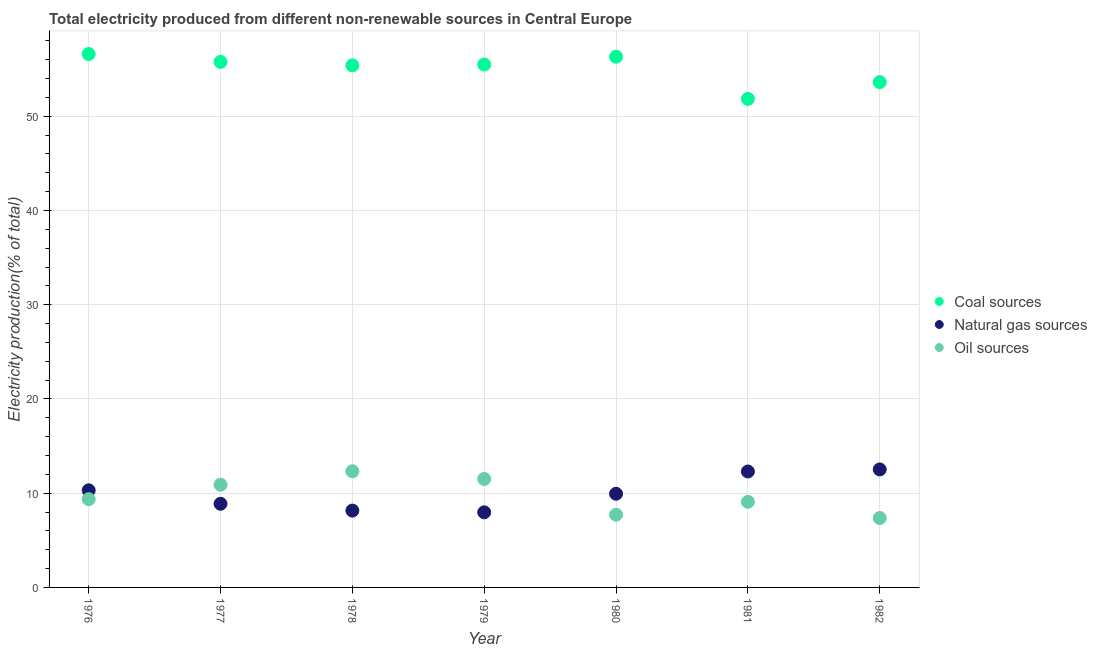How many different coloured dotlines are there?
Ensure brevity in your answer.  3. What is the percentage of electricity produced by oil sources in 1981?
Offer a very short reply. 9.09. Across all years, what is the maximum percentage of electricity produced by coal?
Offer a terse response. 56.61. Across all years, what is the minimum percentage of electricity produced by coal?
Keep it short and to the point. 51.85. In which year was the percentage of electricity produced by coal maximum?
Ensure brevity in your answer.  1976. In which year was the percentage of electricity produced by natural gas minimum?
Your response must be concise. 1979. What is the total percentage of electricity produced by natural gas in the graph?
Your response must be concise. 70.08. What is the difference between the percentage of electricity produced by oil sources in 1976 and that in 1977?
Your answer should be very brief. -1.53. What is the difference between the percentage of electricity produced by coal in 1981 and the percentage of electricity produced by oil sources in 1976?
Offer a very short reply. 42.49. What is the average percentage of electricity produced by coal per year?
Offer a terse response. 55.01. In the year 1981, what is the difference between the percentage of electricity produced by oil sources and percentage of electricity produced by coal?
Give a very brief answer. -42.77. What is the ratio of the percentage of electricity produced by coal in 1977 to that in 1982?
Make the answer very short. 1.04. Is the percentage of electricity produced by oil sources in 1978 less than that in 1982?
Keep it short and to the point. No. What is the difference between the highest and the second highest percentage of electricity produced by natural gas?
Your response must be concise. 0.22. What is the difference between the highest and the lowest percentage of electricity produced by oil sources?
Offer a very short reply. 4.96. In how many years, is the percentage of electricity produced by coal greater than the average percentage of electricity produced by coal taken over all years?
Ensure brevity in your answer.  5. Is the sum of the percentage of electricity produced by natural gas in 1981 and 1982 greater than the maximum percentage of electricity produced by oil sources across all years?
Keep it short and to the point. Yes. Does the percentage of electricity produced by natural gas monotonically increase over the years?
Keep it short and to the point. No. Are the values on the major ticks of Y-axis written in scientific E-notation?
Ensure brevity in your answer.  No. Where does the legend appear in the graph?
Make the answer very short. Center right. How many legend labels are there?
Make the answer very short. 3. What is the title of the graph?
Provide a short and direct response. Total electricity produced from different non-renewable sources in Central Europe. Does "Tertiary education" appear as one of the legend labels in the graph?
Keep it short and to the point. No. What is the Electricity production(% of total) of Coal sources in 1976?
Keep it short and to the point. 56.61. What is the Electricity production(% of total) of Natural gas sources in 1976?
Your answer should be very brief. 10.31. What is the Electricity production(% of total) of Oil sources in 1976?
Offer a terse response. 9.37. What is the Electricity production(% of total) in Coal sources in 1977?
Make the answer very short. 55.77. What is the Electricity production(% of total) of Natural gas sources in 1977?
Your answer should be compact. 8.87. What is the Electricity production(% of total) in Oil sources in 1977?
Your answer should be very brief. 10.9. What is the Electricity production(% of total) of Coal sources in 1978?
Give a very brief answer. 55.41. What is the Electricity production(% of total) in Natural gas sources in 1978?
Provide a short and direct response. 8.15. What is the Electricity production(% of total) of Oil sources in 1978?
Give a very brief answer. 12.33. What is the Electricity production(% of total) in Coal sources in 1979?
Make the answer very short. 55.5. What is the Electricity production(% of total) in Natural gas sources in 1979?
Make the answer very short. 7.97. What is the Electricity production(% of total) of Oil sources in 1979?
Offer a very short reply. 11.52. What is the Electricity production(% of total) of Coal sources in 1980?
Offer a terse response. 56.32. What is the Electricity production(% of total) of Natural gas sources in 1980?
Provide a succinct answer. 9.94. What is the Electricity production(% of total) in Oil sources in 1980?
Offer a very short reply. 7.72. What is the Electricity production(% of total) of Coal sources in 1981?
Your answer should be compact. 51.85. What is the Electricity production(% of total) in Natural gas sources in 1981?
Offer a very short reply. 12.3. What is the Electricity production(% of total) of Oil sources in 1981?
Keep it short and to the point. 9.09. What is the Electricity production(% of total) in Coal sources in 1982?
Provide a succinct answer. 53.63. What is the Electricity production(% of total) of Natural gas sources in 1982?
Make the answer very short. 12.52. What is the Electricity production(% of total) in Oil sources in 1982?
Keep it short and to the point. 7.36. Across all years, what is the maximum Electricity production(% of total) of Coal sources?
Ensure brevity in your answer.  56.61. Across all years, what is the maximum Electricity production(% of total) of Natural gas sources?
Offer a terse response. 12.52. Across all years, what is the maximum Electricity production(% of total) in Oil sources?
Provide a succinct answer. 12.33. Across all years, what is the minimum Electricity production(% of total) in Coal sources?
Keep it short and to the point. 51.85. Across all years, what is the minimum Electricity production(% of total) in Natural gas sources?
Give a very brief answer. 7.97. Across all years, what is the minimum Electricity production(% of total) in Oil sources?
Your answer should be compact. 7.36. What is the total Electricity production(% of total) of Coal sources in the graph?
Offer a very short reply. 385.09. What is the total Electricity production(% of total) of Natural gas sources in the graph?
Offer a very short reply. 70.08. What is the total Electricity production(% of total) of Oil sources in the graph?
Provide a short and direct response. 68.28. What is the difference between the Electricity production(% of total) in Coal sources in 1976 and that in 1977?
Offer a very short reply. 0.84. What is the difference between the Electricity production(% of total) in Natural gas sources in 1976 and that in 1977?
Ensure brevity in your answer.  1.43. What is the difference between the Electricity production(% of total) in Oil sources in 1976 and that in 1977?
Ensure brevity in your answer.  -1.53. What is the difference between the Electricity production(% of total) of Coal sources in 1976 and that in 1978?
Give a very brief answer. 1.2. What is the difference between the Electricity production(% of total) of Natural gas sources in 1976 and that in 1978?
Provide a short and direct response. 2.15. What is the difference between the Electricity production(% of total) in Oil sources in 1976 and that in 1978?
Give a very brief answer. -2.96. What is the difference between the Electricity production(% of total) of Coal sources in 1976 and that in 1979?
Make the answer very short. 1.11. What is the difference between the Electricity production(% of total) of Natural gas sources in 1976 and that in 1979?
Your response must be concise. 2.34. What is the difference between the Electricity production(% of total) in Oil sources in 1976 and that in 1979?
Offer a very short reply. -2.15. What is the difference between the Electricity production(% of total) in Coal sources in 1976 and that in 1980?
Provide a succinct answer. 0.28. What is the difference between the Electricity production(% of total) of Natural gas sources in 1976 and that in 1980?
Ensure brevity in your answer.  0.37. What is the difference between the Electricity production(% of total) in Oil sources in 1976 and that in 1980?
Your answer should be very brief. 1.65. What is the difference between the Electricity production(% of total) in Coal sources in 1976 and that in 1981?
Ensure brevity in your answer.  4.76. What is the difference between the Electricity production(% of total) in Natural gas sources in 1976 and that in 1981?
Ensure brevity in your answer.  -2. What is the difference between the Electricity production(% of total) of Oil sources in 1976 and that in 1981?
Ensure brevity in your answer.  0.28. What is the difference between the Electricity production(% of total) of Coal sources in 1976 and that in 1982?
Your response must be concise. 2.98. What is the difference between the Electricity production(% of total) in Natural gas sources in 1976 and that in 1982?
Give a very brief answer. -2.22. What is the difference between the Electricity production(% of total) in Oil sources in 1976 and that in 1982?
Provide a short and direct response. 2. What is the difference between the Electricity production(% of total) in Coal sources in 1977 and that in 1978?
Provide a short and direct response. 0.36. What is the difference between the Electricity production(% of total) in Natural gas sources in 1977 and that in 1978?
Ensure brevity in your answer.  0.72. What is the difference between the Electricity production(% of total) of Oil sources in 1977 and that in 1978?
Provide a succinct answer. -1.43. What is the difference between the Electricity production(% of total) in Coal sources in 1977 and that in 1979?
Give a very brief answer. 0.28. What is the difference between the Electricity production(% of total) of Natural gas sources in 1977 and that in 1979?
Your answer should be very brief. 0.9. What is the difference between the Electricity production(% of total) in Oil sources in 1977 and that in 1979?
Your answer should be compact. -0.62. What is the difference between the Electricity production(% of total) of Coal sources in 1977 and that in 1980?
Ensure brevity in your answer.  -0.55. What is the difference between the Electricity production(% of total) of Natural gas sources in 1977 and that in 1980?
Give a very brief answer. -1.07. What is the difference between the Electricity production(% of total) in Oil sources in 1977 and that in 1980?
Provide a short and direct response. 3.18. What is the difference between the Electricity production(% of total) of Coal sources in 1977 and that in 1981?
Offer a very short reply. 3.92. What is the difference between the Electricity production(% of total) in Natural gas sources in 1977 and that in 1981?
Provide a short and direct response. -3.43. What is the difference between the Electricity production(% of total) of Oil sources in 1977 and that in 1981?
Your response must be concise. 1.81. What is the difference between the Electricity production(% of total) in Coal sources in 1977 and that in 1982?
Provide a succinct answer. 2.14. What is the difference between the Electricity production(% of total) in Natural gas sources in 1977 and that in 1982?
Your response must be concise. -3.65. What is the difference between the Electricity production(% of total) in Oil sources in 1977 and that in 1982?
Keep it short and to the point. 3.53. What is the difference between the Electricity production(% of total) in Coal sources in 1978 and that in 1979?
Your answer should be compact. -0.09. What is the difference between the Electricity production(% of total) of Natural gas sources in 1978 and that in 1979?
Your answer should be very brief. 0.18. What is the difference between the Electricity production(% of total) of Oil sources in 1978 and that in 1979?
Provide a short and direct response. 0.81. What is the difference between the Electricity production(% of total) of Coal sources in 1978 and that in 1980?
Your answer should be compact. -0.92. What is the difference between the Electricity production(% of total) of Natural gas sources in 1978 and that in 1980?
Give a very brief answer. -1.79. What is the difference between the Electricity production(% of total) of Oil sources in 1978 and that in 1980?
Make the answer very short. 4.61. What is the difference between the Electricity production(% of total) of Coal sources in 1978 and that in 1981?
Your response must be concise. 3.56. What is the difference between the Electricity production(% of total) in Natural gas sources in 1978 and that in 1981?
Offer a very short reply. -4.15. What is the difference between the Electricity production(% of total) of Oil sources in 1978 and that in 1981?
Offer a terse response. 3.24. What is the difference between the Electricity production(% of total) in Coal sources in 1978 and that in 1982?
Offer a very short reply. 1.78. What is the difference between the Electricity production(% of total) in Natural gas sources in 1978 and that in 1982?
Offer a terse response. -4.37. What is the difference between the Electricity production(% of total) of Oil sources in 1978 and that in 1982?
Offer a terse response. 4.96. What is the difference between the Electricity production(% of total) of Coal sources in 1979 and that in 1980?
Provide a short and direct response. -0.83. What is the difference between the Electricity production(% of total) of Natural gas sources in 1979 and that in 1980?
Your answer should be very brief. -1.97. What is the difference between the Electricity production(% of total) in Oil sources in 1979 and that in 1980?
Offer a terse response. 3.8. What is the difference between the Electricity production(% of total) in Coal sources in 1979 and that in 1981?
Make the answer very short. 3.65. What is the difference between the Electricity production(% of total) in Natural gas sources in 1979 and that in 1981?
Offer a terse response. -4.33. What is the difference between the Electricity production(% of total) of Oil sources in 1979 and that in 1981?
Give a very brief answer. 2.43. What is the difference between the Electricity production(% of total) in Coal sources in 1979 and that in 1982?
Your answer should be very brief. 1.87. What is the difference between the Electricity production(% of total) of Natural gas sources in 1979 and that in 1982?
Provide a short and direct response. -4.55. What is the difference between the Electricity production(% of total) of Oil sources in 1979 and that in 1982?
Offer a very short reply. 4.15. What is the difference between the Electricity production(% of total) in Coal sources in 1980 and that in 1981?
Your answer should be compact. 4.47. What is the difference between the Electricity production(% of total) of Natural gas sources in 1980 and that in 1981?
Make the answer very short. -2.36. What is the difference between the Electricity production(% of total) of Oil sources in 1980 and that in 1981?
Your answer should be very brief. -1.37. What is the difference between the Electricity production(% of total) in Coal sources in 1980 and that in 1982?
Make the answer very short. 2.7. What is the difference between the Electricity production(% of total) of Natural gas sources in 1980 and that in 1982?
Provide a succinct answer. -2.58. What is the difference between the Electricity production(% of total) of Oil sources in 1980 and that in 1982?
Your answer should be very brief. 0.36. What is the difference between the Electricity production(% of total) in Coal sources in 1981 and that in 1982?
Give a very brief answer. -1.78. What is the difference between the Electricity production(% of total) of Natural gas sources in 1981 and that in 1982?
Provide a succinct answer. -0.22. What is the difference between the Electricity production(% of total) in Oil sources in 1981 and that in 1982?
Offer a terse response. 1.72. What is the difference between the Electricity production(% of total) in Coal sources in 1976 and the Electricity production(% of total) in Natural gas sources in 1977?
Offer a terse response. 47.73. What is the difference between the Electricity production(% of total) in Coal sources in 1976 and the Electricity production(% of total) in Oil sources in 1977?
Make the answer very short. 45.71. What is the difference between the Electricity production(% of total) of Natural gas sources in 1976 and the Electricity production(% of total) of Oil sources in 1977?
Your response must be concise. -0.59. What is the difference between the Electricity production(% of total) in Coal sources in 1976 and the Electricity production(% of total) in Natural gas sources in 1978?
Offer a very short reply. 48.45. What is the difference between the Electricity production(% of total) in Coal sources in 1976 and the Electricity production(% of total) in Oil sources in 1978?
Offer a very short reply. 44.28. What is the difference between the Electricity production(% of total) in Natural gas sources in 1976 and the Electricity production(% of total) in Oil sources in 1978?
Your answer should be compact. -2.02. What is the difference between the Electricity production(% of total) of Coal sources in 1976 and the Electricity production(% of total) of Natural gas sources in 1979?
Provide a short and direct response. 48.64. What is the difference between the Electricity production(% of total) of Coal sources in 1976 and the Electricity production(% of total) of Oil sources in 1979?
Provide a short and direct response. 45.09. What is the difference between the Electricity production(% of total) in Natural gas sources in 1976 and the Electricity production(% of total) in Oil sources in 1979?
Provide a short and direct response. -1.21. What is the difference between the Electricity production(% of total) of Coal sources in 1976 and the Electricity production(% of total) of Natural gas sources in 1980?
Ensure brevity in your answer.  46.67. What is the difference between the Electricity production(% of total) in Coal sources in 1976 and the Electricity production(% of total) in Oil sources in 1980?
Make the answer very short. 48.89. What is the difference between the Electricity production(% of total) of Natural gas sources in 1976 and the Electricity production(% of total) of Oil sources in 1980?
Your response must be concise. 2.59. What is the difference between the Electricity production(% of total) in Coal sources in 1976 and the Electricity production(% of total) in Natural gas sources in 1981?
Provide a short and direct response. 44.31. What is the difference between the Electricity production(% of total) in Coal sources in 1976 and the Electricity production(% of total) in Oil sources in 1981?
Offer a terse response. 47.52. What is the difference between the Electricity production(% of total) of Natural gas sources in 1976 and the Electricity production(% of total) of Oil sources in 1981?
Offer a terse response. 1.22. What is the difference between the Electricity production(% of total) in Coal sources in 1976 and the Electricity production(% of total) in Natural gas sources in 1982?
Offer a very short reply. 44.09. What is the difference between the Electricity production(% of total) in Coal sources in 1976 and the Electricity production(% of total) in Oil sources in 1982?
Keep it short and to the point. 49.24. What is the difference between the Electricity production(% of total) in Natural gas sources in 1976 and the Electricity production(% of total) in Oil sources in 1982?
Provide a short and direct response. 2.94. What is the difference between the Electricity production(% of total) of Coal sources in 1977 and the Electricity production(% of total) of Natural gas sources in 1978?
Give a very brief answer. 47.62. What is the difference between the Electricity production(% of total) of Coal sources in 1977 and the Electricity production(% of total) of Oil sources in 1978?
Offer a terse response. 43.44. What is the difference between the Electricity production(% of total) of Natural gas sources in 1977 and the Electricity production(% of total) of Oil sources in 1978?
Keep it short and to the point. -3.45. What is the difference between the Electricity production(% of total) of Coal sources in 1977 and the Electricity production(% of total) of Natural gas sources in 1979?
Offer a very short reply. 47.8. What is the difference between the Electricity production(% of total) in Coal sources in 1977 and the Electricity production(% of total) in Oil sources in 1979?
Your response must be concise. 44.26. What is the difference between the Electricity production(% of total) in Natural gas sources in 1977 and the Electricity production(% of total) in Oil sources in 1979?
Provide a short and direct response. -2.64. What is the difference between the Electricity production(% of total) in Coal sources in 1977 and the Electricity production(% of total) in Natural gas sources in 1980?
Provide a short and direct response. 45.83. What is the difference between the Electricity production(% of total) of Coal sources in 1977 and the Electricity production(% of total) of Oil sources in 1980?
Offer a terse response. 48.05. What is the difference between the Electricity production(% of total) in Natural gas sources in 1977 and the Electricity production(% of total) in Oil sources in 1980?
Your answer should be very brief. 1.15. What is the difference between the Electricity production(% of total) of Coal sources in 1977 and the Electricity production(% of total) of Natural gas sources in 1981?
Make the answer very short. 43.47. What is the difference between the Electricity production(% of total) in Coal sources in 1977 and the Electricity production(% of total) in Oil sources in 1981?
Keep it short and to the point. 46.69. What is the difference between the Electricity production(% of total) in Natural gas sources in 1977 and the Electricity production(% of total) in Oil sources in 1981?
Provide a short and direct response. -0.21. What is the difference between the Electricity production(% of total) of Coal sources in 1977 and the Electricity production(% of total) of Natural gas sources in 1982?
Provide a succinct answer. 43.25. What is the difference between the Electricity production(% of total) of Coal sources in 1977 and the Electricity production(% of total) of Oil sources in 1982?
Give a very brief answer. 48.41. What is the difference between the Electricity production(% of total) of Natural gas sources in 1977 and the Electricity production(% of total) of Oil sources in 1982?
Give a very brief answer. 1.51. What is the difference between the Electricity production(% of total) in Coal sources in 1978 and the Electricity production(% of total) in Natural gas sources in 1979?
Provide a succinct answer. 47.44. What is the difference between the Electricity production(% of total) in Coal sources in 1978 and the Electricity production(% of total) in Oil sources in 1979?
Ensure brevity in your answer.  43.89. What is the difference between the Electricity production(% of total) in Natural gas sources in 1978 and the Electricity production(% of total) in Oil sources in 1979?
Provide a short and direct response. -3.36. What is the difference between the Electricity production(% of total) of Coal sources in 1978 and the Electricity production(% of total) of Natural gas sources in 1980?
Ensure brevity in your answer.  45.47. What is the difference between the Electricity production(% of total) of Coal sources in 1978 and the Electricity production(% of total) of Oil sources in 1980?
Provide a succinct answer. 47.69. What is the difference between the Electricity production(% of total) of Natural gas sources in 1978 and the Electricity production(% of total) of Oil sources in 1980?
Ensure brevity in your answer.  0.43. What is the difference between the Electricity production(% of total) of Coal sources in 1978 and the Electricity production(% of total) of Natural gas sources in 1981?
Provide a short and direct response. 43.11. What is the difference between the Electricity production(% of total) of Coal sources in 1978 and the Electricity production(% of total) of Oil sources in 1981?
Offer a very short reply. 46.32. What is the difference between the Electricity production(% of total) of Natural gas sources in 1978 and the Electricity production(% of total) of Oil sources in 1981?
Keep it short and to the point. -0.93. What is the difference between the Electricity production(% of total) of Coal sources in 1978 and the Electricity production(% of total) of Natural gas sources in 1982?
Keep it short and to the point. 42.88. What is the difference between the Electricity production(% of total) in Coal sources in 1978 and the Electricity production(% of total) in Oil sources in 1982?
Offer a very short reply. 48.04. What is the difference between the Electricity production(% of total) in Natural gas sources in 1978 and the Electricity production(% of total) in Oil sources in 1982?
Make the answer very short. 0.79. What is the difference between the Electricity production(% of total) of Coal sources in 1979 and the Electricity production(% of total) of Natural gas sources in 1980?
Your answer should be very brief. 45.55. What is the difference between the Electricity production(% of total) in Coal sources in 1979 and the Electricity production(% of total) in Oil sources in 1980?
Ensure brevity in your answer.  47.78. What is the difference between the Electricity production(% of total) of Natural gas sources in 1979 and the Electricity production(% of total) of Oil sources in 1980?
Keep it short and to the point. 0.25. What is the difference between the Electricity production(% of total) of Coal sources in 1979 and the Electricity production(% of total) of Natural gas sources in 1981?
Your response must be concise. 43.19. What is the difference between the Electricity production(% of total) of Coal sources in 1979 and the Electricity production(% of total) of Oil sources in 1981?
Keep it short and to the point. 46.41. What is the difference between the Electricity production(% of total) of Natural gas sources in 1979 and the Electricity production(% of total) of Oil sources in 1981?
Make the answer very short. -1.11. What is the difference between the Electricity production(% of total) in Coal sources in 1979 and the Electricity production(% of total) in Natural gas sources in 1982?
Your answer should be compact. 42.97. What is the difference between the Electricity production(% of total) of Coal sources in 1979 and the Electricity production(% of total) of Oil sources in 1982?
Provide a succinct answer. 48.13. What is the difference between the Electricity production(% of total) of Natural gas sources in 1979 and the Electricity production(% of total) of Oil sources in 1982?
Your response must be concise. 0.61. What is the difference between the Electricity production(% of total) in Coal sources in 1980 and the Electricity production(% of total) in Natural gas sources in 1981?
Make the answer very short. 44.02. What is the difference between the Electricity production(% of total) of Coal sources in 1980 and the Electricity production(% of total) of Oil sources in 1981?
Provide a short and direct response. 47.24. What is the difference between the Electricity production(% of total) in Natural gas sources in 1980 and the Electricity production(% of total) in Oil sources in 1981?
Offer a very short reply. 0.86. What is the difference between the Electricity production(% of total) of Coal sources in 1980 and the Electricity production(% of total) of Natural gas sources in 1982?
Provide a succinct answer. 43.8. What is the difference between the Electricity production(% of total) in Coal sources in 1980 and the Electricity production(% of total) in Oil sources in 1982?
Your response must be concise. 48.96. What is the difference between the Electricity production(% of total) of Natural gas sources in 1980 and the Electricity production(% of total) of Oil sources in 1982?
Keep it short and to the point. 2.58. What is the difference between the Electricity production(% of total) of Coal sources in 1981 and the Electricity production(% of total) of Natural gas sources in 1982?
Offer a very short reply. 39.33. What is the difference between the Electricity production(% of total) of Coal sources in 1981 and the Electricity production(% of total) of Oil sources in 1982?
Ensure brevity in your answer.  44.49. What is the difference between the Electricity production(% of total) in Natural gas sources in 1981 and the Electricity production(% of total) in Oil sources in 1982?
Ensure brevity in your answer.  4.94. What is the average Electricity production(% of total) of Coal sources per year?
Your response must be concise. 55.01. What is the average Electricity production(% of total) in Natural gas sources per year?
Offer a terse response. 10.01. What is the average Electricity production(% of total) of Oil sources per year?
Your answer should be very brief. 9.75. In the year 1976, what is the difference between the Electricity production(% of total) of Coal sources and Electricity production(% of total) of Natural gas sources?
Offer a terse response. 46.3. In the year 1976, what is the difference between the Electricity production(% of total) of Coal sources and Electricity production(% of total) of Oil sources?
Give a very brief answer. 47.24. In the year 1976, what is the difference between the Electricity production(% of total) in Natural gas sources and Electricity production(% of total) in Oil sources?
Keep it short and to the point. 0.94. In the year 1977, what is the difference between the Electricity production(% of total) of Coal sources and Electricity production(% of total) of Natural gas sources?
Keep it short and to the point. 46.9. In the year 1977, what is the difference between the Electricity production(% of total) of Coal sources and Electricity production(% of total) of Oil sources?
Make the answer very short. 44.87. In the year 1977, what is the difference between the Electricity production(% of total) of Natural gas sources and Electricity production(% of total) of Oil sources?
Provide a short and direct response. -2.02. In the year 1978, what is the difference between the Electricity production(% of total) of Coal sources and Electricity production(% of total) of Natural gas sources?
Your answer should be very brief. 47.25. In the year 1978, what is the difference between the Electricity production(% of total) in Coal sources and Electricity production(% of total) in Oil sources?
Offer a very short reply. 43.08. In the year 1978, what is the difference between the Electricity production(% of total) in Natural gas sources and Electricity production(% of total) in Oil sources?
Offer a very short reply. -4.17. In the year 1979, what is the difference between the Electricity production(% of total) in Coal sources and Electricity production(% of total) in Natural gas sources?
Offer a very short reply. 47.53. In the year 1979, what is the difference between the Electricity production(% of total) in Coal sources and Electricity production(% of total) in Oil sources?
Your response must be concise. 43.98. In the year 1979, what is the difference between the Electricity production(% of total) of Natural gas sources and Electricity production(% of total) of Oil sources?
Your answer should be very brief. -3.54. In the year 1980, what is the difference between the Electricity production(% of total) in Coal sources and Electricity production(% of total) in Natural gas sources?
Your answer should be compact. 46.38. In the year 1980, what is the difference between the Electricity production(% of total) in Coal sources and Electricity production(% of total) in Oil sources?
Your answer should be compact. 48.6. In the year 1980, what is the difference between the Electricity production(% of total) of Natural gas sources and Electricity production(% of total) of Oil sources?
Give a very brief answer. 2.22. In the year 1981, what is the difference between the Electricity production(% of total) in Coal sources and Electricity production(% of total) in Natural gas sources?
Provide a short and direct response. 39.55. In the year 1981, what is the difference between the Electricity production(% of total) of Coal sources and Electricity production(% of total) of Oil sources?
Your answer should be very brief. 42.77. In the year 1981, what is the difference between the Electricity production(% of total) in Natural gas sources and Electricity production(% of total) in Oil sources?
Keep it short and to the point. 3.22. In the year 1982, what is the difference between the Electricity production(% of total) of Coal sources and Electricity production(% of total) of Natural gas sources?
Keep it short and to the point. 41.1. In the year 1982, what is the difference between the Electricity production(% of total) in Coal sources and Electricity production(% of total) in Oil sources?
Offer a very short reply. 46.26. In the year 1982, what is the difference between the Electricity production(% of total) of Natural gas sources and Electricity production(% of total) of Oil sources?
Your response must be concise. 5.16. What is the ratio of the Electricity production(% of total) in Coal sources in 1976 to that in 1977?
Offer a terse response. 1.01. What is the ratio of the Electricity production(% of total) in Natural gas sources in 1976 to that in 1977?
Your answer should be very brief. 1.16. What is the ratio of the Electricity production(% of total) of Oil sources in 1976 to that in 1977?
Your answer should be very brief. 0.86. What is the ratio of the Electricity production(% of total) in Coal sources in 1976 to that in 1978?
Your answer should be very brief. 1.02. What is the ratio of the Electricity production(% of total) in Natural gas sources in 1976 to that in 1978?
Offer a terse response. 1.26. What is the ratio of the Electricity production(% of total) in Oil sources in 1976 to that in 1978?
Provide a succinct answer. 0.76. What is the ratio of the Electricity production(% of total) of Natural gas sources in 1976 to that in 1979?
Your answer should be compact. 1.29. What is the ratio of the Electricity production(% of total) of Oil sources in 1976 to that in 1979?
Your answer should be very brief. 0.81. What is the ratio of the Electricity production(% of total) in Coal sources in 1976 to that in 1980?
Provide a short and direct response. 1.01. What is the ratio of the Electricity production(% of total) of Natural gas sources in 1976 to that in 1980?
Your answer should be compact. 1.04. What is the ratio of the Electricity production(% of total) of Oil sources in 1976 to that in 1980?
Your response must be concise. 1.21. What is the ratio of the Electricity production(% of total) in Coal sources in 1976 to that in 1981?
Provide a succinct answer. 1.09. What is the ratio of the Electricity production(% of total) of Natural gas sources in 1976 to that in 1981?
Keep it short and to the point. 0.84. What is the ratio of the Electricity production(% of total) of Oil sources in 1976 to that in 1981?
Provide a short and direct response. 1.03. What is the ratio of the Electricity production(% of total) of Coal sources in 1976 to that in 1982?
Keep it short and to the point. 1.06. What is the ratio of the Electricity production(% of total) in Natural gas sources in 1976 to that in 1982?
Your response must be concise. 0.82. What is the ratio of the Electricity production(% of total) of Oil sources in 1976 to that in 1982?
Ensure brevity in your answer.  1.27. What is the ratio of the Electricity production(% of total) in Coal sources in 1977 to that in 1978?
Keep it short and to the point. 1.01. What is the ratio of the Electricity production(% of total) in Natural gas sources in 1977 to that in 1978?
Offer a very short reply. 1.09. What is the ratio of the Electricity production(% of total) of Oil sources in 1977 to that in 1978?
Make the answer very short. 0.88. What is the ratio of the Electricity production(% of total) of Natural gas sources in 1977 to that in 1979?
Keep it short and to the point. 1.11. What is the ratio of the Electricity production(% of total) of Oil sources in 1977 to that in 1979?
Offer a terse response. 0.95. What is the ratio of the Electricity production(% of total) of Coal sources in 1977 to that in 1980?
Give a very brief answer. 0.99. What is the ratio of the Electricity production(% of total) in Natural gas sources in 1977 to that in 1980?
Keep it short and to the point. 0.89. What is the ratio of the Electricity production(% of total) in Oil sources in 1977 to that in 1980?
Your response must be concise. 1.41. What is the ratio of the Electricity production(% of total) of Coal sources in 1977 to that in 1981?
Your answer should be very brief. 1.08. What is the ratio of the Electricity production(% of total) of Natural gas sources in 1977 to that in 1981?
Make the answer very short. 0.72. What is the ratio of the Electricity production(% of total) in Oil sources in 1977 to that in 1981?
Your response must be concise. 1.2. What is the ratio of the Electricity production(% of total) of Coal sources in 1977 to that in 1982?
Your answer should be very brief. 1.04. What is the ratio of the Electricity production(% of total) of Natural gas sources in 1977 to that in 1982?
Provide a short and direct response. 0.71. What is the ratio of the Electricity production(% of total) in Oil sources in 1977 to that in 1982?
Offer a very short reply. 1.48. What is the ratio of the Electricity production(% of total) of Natural gas sources in 1978 to that in 1979?
Make the answer very short. 1.02. What is the ratio of the Electricity production(% of total) in Oil sources in 1978 to that in 1979?
Your answer should be compact. 1.07. What is the ratio of the Electricity production(% of total) in Coal sources in 1978 to that in 1980?
Keep it short and to the point. 0.98. What is the ratio of the Electricity production(% of total) in Natural gas sources in 1978 to that in 1980?
Ensure brevity in your answer.  0.82. What is the ratio of the Electricity production(% of total) of Oil sources in 1978 to that in 1980?
Provide a succinct answer. 1.6. What is the ratio of the Electricity production(% of total) in Coal sources in 1978 to that in 1981?
Offer a very short reply. 1.07. What is the ratio of the Electricity production(% of total) in Natural gas sources in 1978 to that in 1981?
Your response must be concise. 0.66. What is the ratio of the Electricity production(% of total) in Oil sources in 1978 to that in 1981?
Make the answer very short. 1.36. What is the ratio of the Electricity production(% of total) in Coal sources in 1978 to that in 1982?
Offer a very short reply. 1.03. What is the ratio of the Electricity production(% of total) in Natural gas sources in 1978 to that in 1982?
Make the answer very short. 0.65. What is the ratio of the Electricity production(% of total) in Oil sources in 1978 to that in 1982?
Make the answer very short. 1.67. What is the ratio of the Electricity production(% of total) in Natural gas sources in 1979 to that in 1980?
Provide a short and direct response. 0.8. What is the ratio of the Electricity production(% of total) in Oil sources in 1979 to that in 1980?
Provide a succinct answer. 1.49. What is the ratio of the Electricity production(% of total) in Coal sources in 1979 to that in 1981?
Your answer should be compact. 1.07. What is the ratio of the Electricity production(% of total) in Natural gas sources in 1979 to that in 1981?
Your answer should be compact. 0.65. What is the ratio of the Electricity production(% of total) of Oil sources in 1979 to that in 1981?
Provide a succinct answer. 1.27. What is the ratio of the Electricity production(% of total) of Coal sources in 1979 to that in 1982?
Your answer should be very brief. 1.03. What is the ratio of the Electricity production(% of total) of Natural gas sources in 1979 to that in 1982?
Give a very brief answer. 0.64. What is the ratio of the Electricity production(% of total) in Oil sources in 1979 to that in 1982?
Keep it short and to the point. 1.56. What is the ratio of the Electricity production(% of total) in Coal sources in 1980 to that in 1981?
Provide a succinct answer. 1.09. What is the ratio of the Electricity production(% of total) in Natural gas sources in 1980 to that in 1981?
Keep it short and to the point. 0.81. What is the ratio of the Electricity production(% of total) of Oil sources in 1980 to that in 1981?
Keep it short and to the point. 0.85. What is the ratio of the Electricity production(% of total) of Coal sources in 1980 to that in 1982?
Offer a very short reply. 1.05. What is the ratio of the Electricity production(% of total) of Natural gas sources in 1980 to that in 1982?
Make the answer very short. 0.79. What is the ratio of the Electricity production(% of total) of Oil sources in 1980 to that in 1982?
Offer a very short reply. 1.05. What is the ratio of the Electricity production(% of total) of Coal sources in 1981 to that in 1982?
Provide a succinct answer. 0.97. What is the ratio of the Electricity production(% of total) in Natural gas sources in 1981 to that in 1982?
Your answer should be compact. 0.98. What is the ratio of the Electricity production(% of total) in Oil sources in 1981 to that in 1982?
Provide a short and direct response. 1.23. What is the difference between the highest and the second highest Electricity production(% of total) in Coal sources?
Your answer should be very brief. 0.28. What is the difference between the highest and the second highest Electricity production(% of total) in Natural gas sources?
Offer a terse response. 0.22. What is the difference between the highest and the second highest Electricity production(% of total) in Oil sources?
Make the answer very short. 0.81. What is the difference between the highest and the lowest Electricity production(% of total) of Coal sources?
Give a very brief answer. 4.76. What is the difference between the highest and the lowest Electricity production(% of total) in Natural gas sources?
Make the answer very short. 4.55. What is the difference between the highest and the lowest Electricity production(% of total) of Oil sources?
Ensure brevity in your answer.  4.96. 